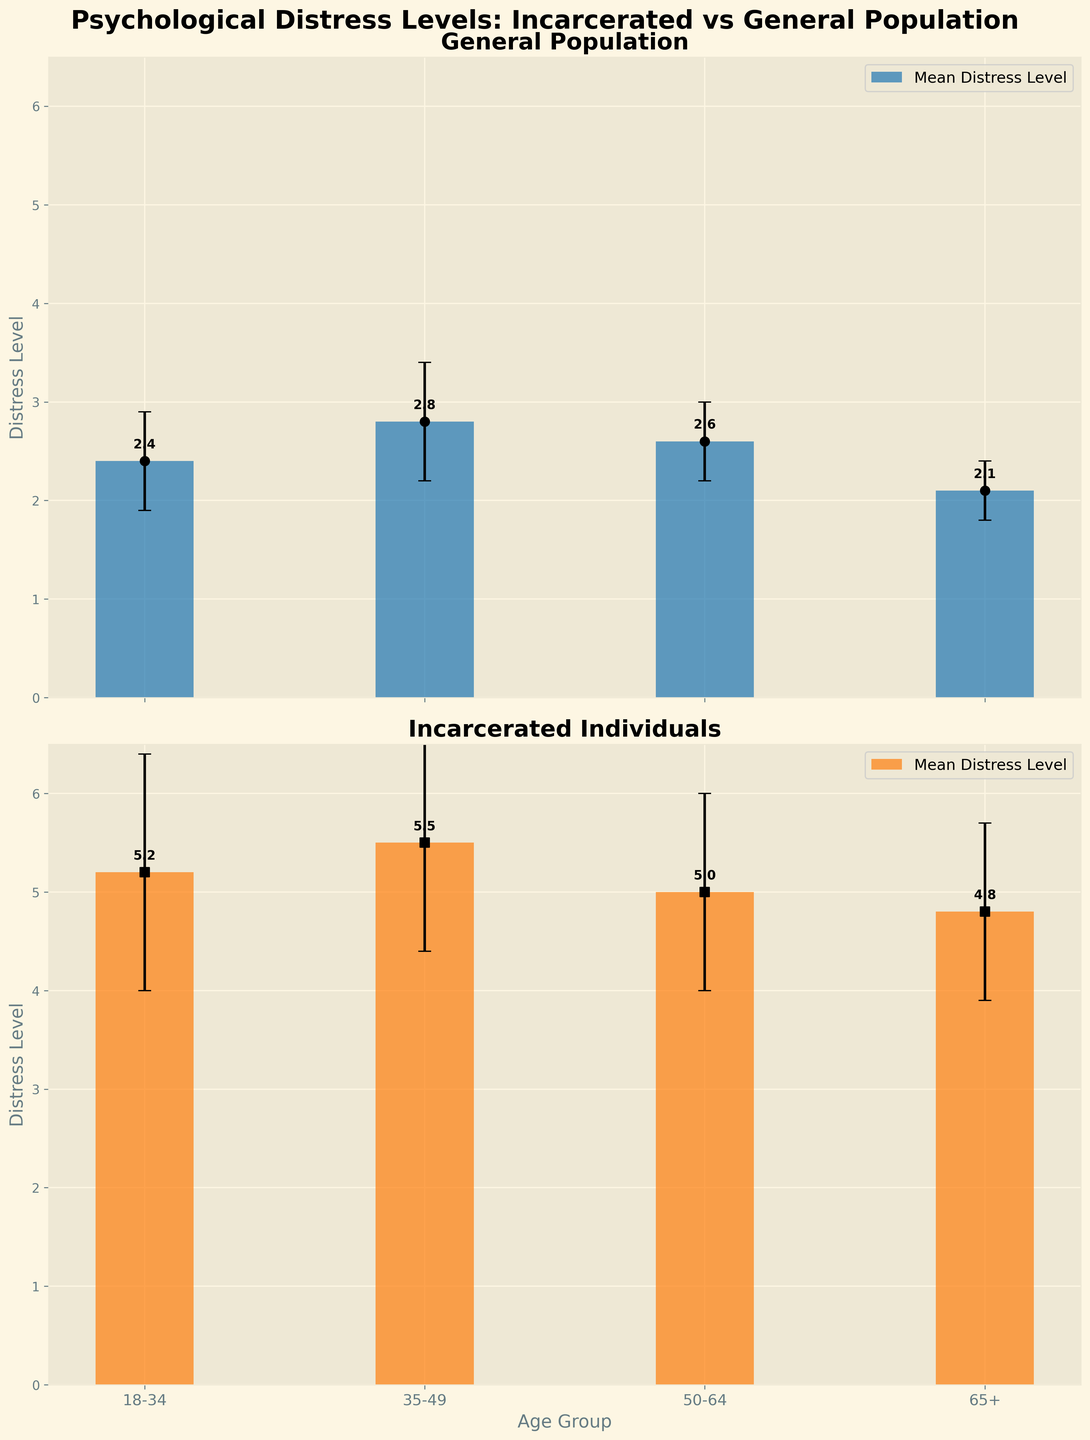What's the title of the figure? The title is displayed at the top of the figure in bold and large font. It reads 'Psychological Distress Levels: Incarcerated vs General Population'.
Answer: Psychological Distress Levels: Incarcerated vs General Population What is the mean distress level for incarcerated individuals aged 18-34? The bar representing the incarcerated individuals aged 18-34 shows a height of 5.2 on the y-axis, which corresponds to the mean distress level.
Answer: 5.2 Which age group has the highest mean distress level overall? By comparing the heights of all bars, the tallest bar is for incarcerated individuals aged 35-49 with a mean distress level of 5.5.
Answer: 35-49 (Incarcerated) What is the distress level range for the general population aged 35-49 considering the error bars? The error bars for the general population aged 35-49 extend 0.6 units above and below the mean distress level of 2.8, so the range is [2.2, 3.4].
Answer: [2.2, 3.4] How does the mean distress level change from age group 18-34 to 65+ for the incarcerated individuals? Observing the bars for incarcerated individuals, the mean distress level drops from 5.2 (18-34), to 5.5 (35-49), to 5.0 (50-64), and then to 4.8 (65+).
Answer: It decreases Which group has the largest standard deviation in their distress levels? The error bars indicate the variability (standard deviation). The incarcerated individuals aged 18-34 have the largest error bars, representing a standard deviation of 1.2.
Answer: Incarcerated 18-34 What is the overall trend in distress levels across different age groups for the general population? The general population shows a trend where the distress levels slightly increase from 18-34 (2.4) to 35-49 (2.8), slightly decrease at 50-64 (2.6), and then decrease more for 65+ (2.1).
Answer: Slight increase then decrease How much higher is the distress level for incarcerated individuals aged 18-34 compared to the general population of the same age group? The mean distress level for incarcerated individuals aged 18-34 is 5.2 and for the general population aged 18-34 it is 2.4. The difference is 5.2 - 2.4 = 2.8.
Answer: 2.8 What are the age groups represented on the x-axis? The labels on the x-axis show '18-34', '35-49', '50-64', and '65+'. These are the age groups represented in the figure.
Answer: 18-34, 35-49, 50-64, 65+ Are the error bars longer for incarcerated individuals or the general population? Observing the error bars, those for incarcerated individuals are generally longer than the error bars for the general population, indicating higher variability.
Answer: Incarcerated individuals 